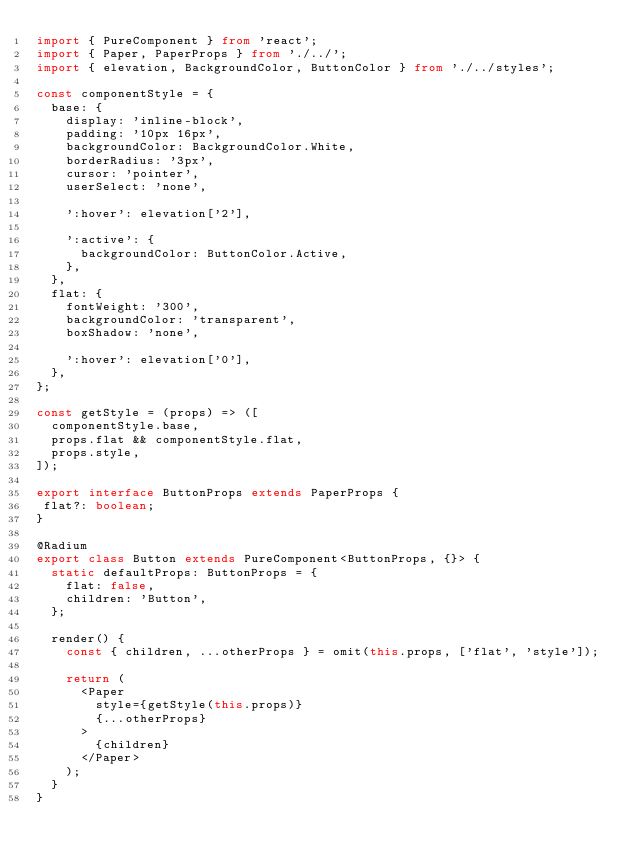<code> <loc_0><loc_0><loc_500><loc_500><_TypeScript_>import { PureComponent } from 'react';
import { Paper, PaperProps } from './../';
import { elevation, BackgroundColor, ButtonColor } from './../styles';

const componentStyle = {
  base: {
    display: 'inline-block',
    padding: '10px 16px',
    backgroundColor: BackgroundColor.White,
    borderRadius: '3px',
    cursor: 'pointer',
    userSelect: 'none',

    ':hover': elevation['2'],

    ':active': {
      backgroundColor: ButtonColor.Active,
    },
  },
  flat: {
    fontWeight: '300',
    backgroundColor: 'transparent',
    boxShadow: 'none',

    ':hover': elevation['0'],
  },
};

const getStyle = (props) => ([
  componentStyle.base,
  props.flat && componentStyle.flat,
  props.style,
]);

export interface ButtonProps extends PaperProps {
 flat?: boolean;
}

@Radium
export class Button extends PureComponent<ButtonProps, {}> {
  static defaultProps: ButtonProps = {
    flat: false,
    children: 'Button',
  };

  render() {
    const { children, ...otherProps } = omit(this.props, ['flat', 'style']);

    return (
      <Paper
        style={getStyle(this.props)}
        {...otherProps}
      >
        {children}
      </Paper>
    );
  }
}
</code> 